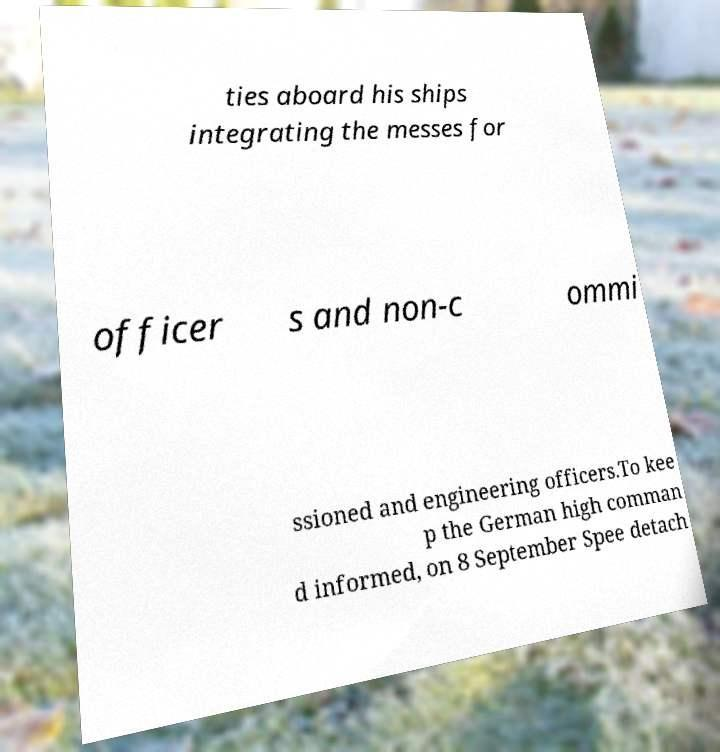There's text embedded in this image that I need extracted. Can you transcribe it verbatim? ties aboard his ships integrating the messes for officer s and non-c ommi ssioned and engineering officers.To kee p the German high comman d informed, on 8 September Spee detach 